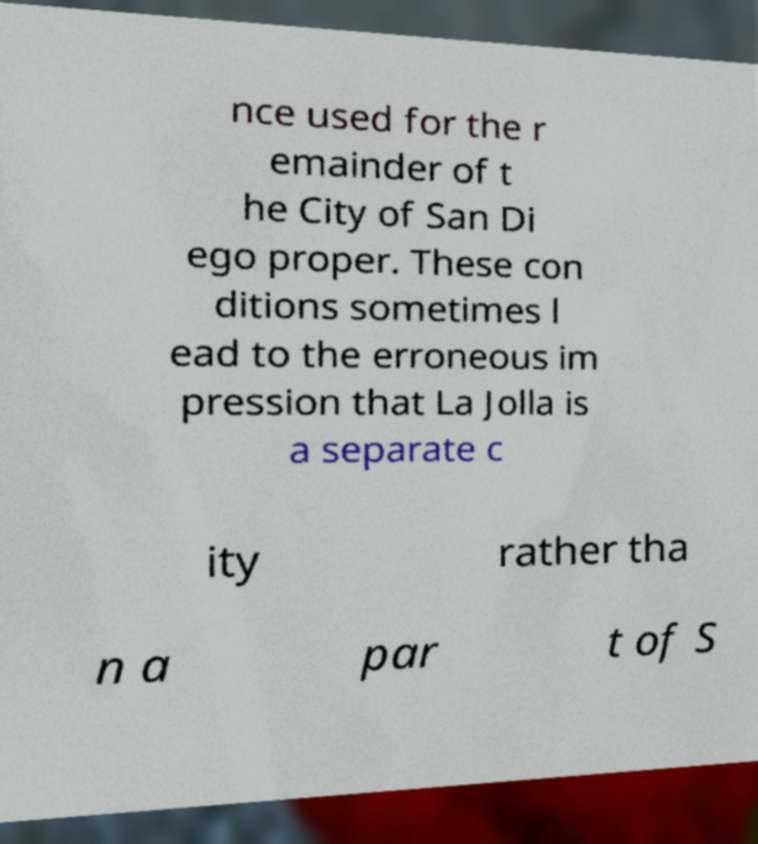Please read and relay the text visible in this image. What does it say? nce used for the r emainder of t he City of San Di ego proper. These con ditions sometimes l ead to the erroneous im pression that La Jolla is a separate c ity rather tha n a par t of S 